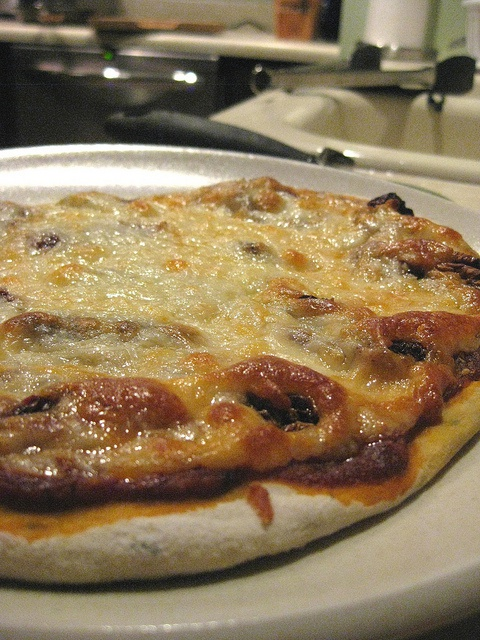Describe the objects in this image and their specific colors. I can see pizza in gray, tan, olive, and maroon tones, sink in gray, olive, and tan tones, and knife in gray, black, and darkgray tones in this image. 